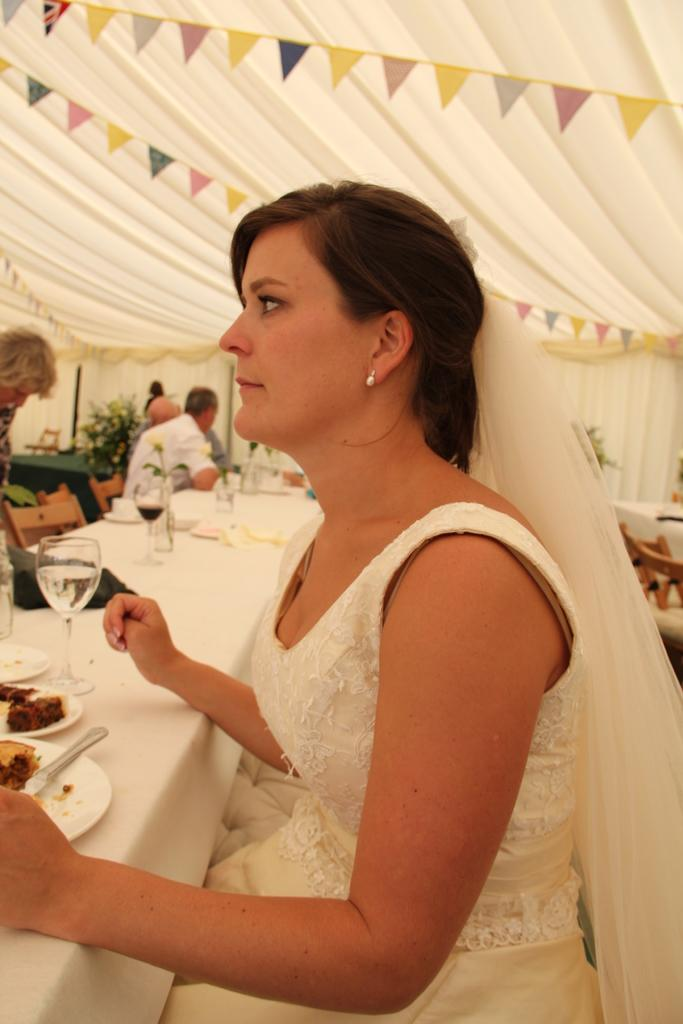What is the woman in the image wearing? The woman is wearing a white dress in the image. What is the woman doing in the image? The woman is sitting in a chair in the image. What is in front of the woman? There is a table in front of the woman. What is on the table? The table has eatables and drinks on it. Can you describe the people in the background of the image? There are people in the background of the image, but their specific actions or appearances are not mentioned in the provided facts. How many frogs are sitting on the table with the woman in the image? There are no frogs present in the image; the table has eatables and drinks on it. What is the purpose of the table's expansion in the image? There is no mention of the table expanding in the image, as the provided facts only describe the items on the table. 